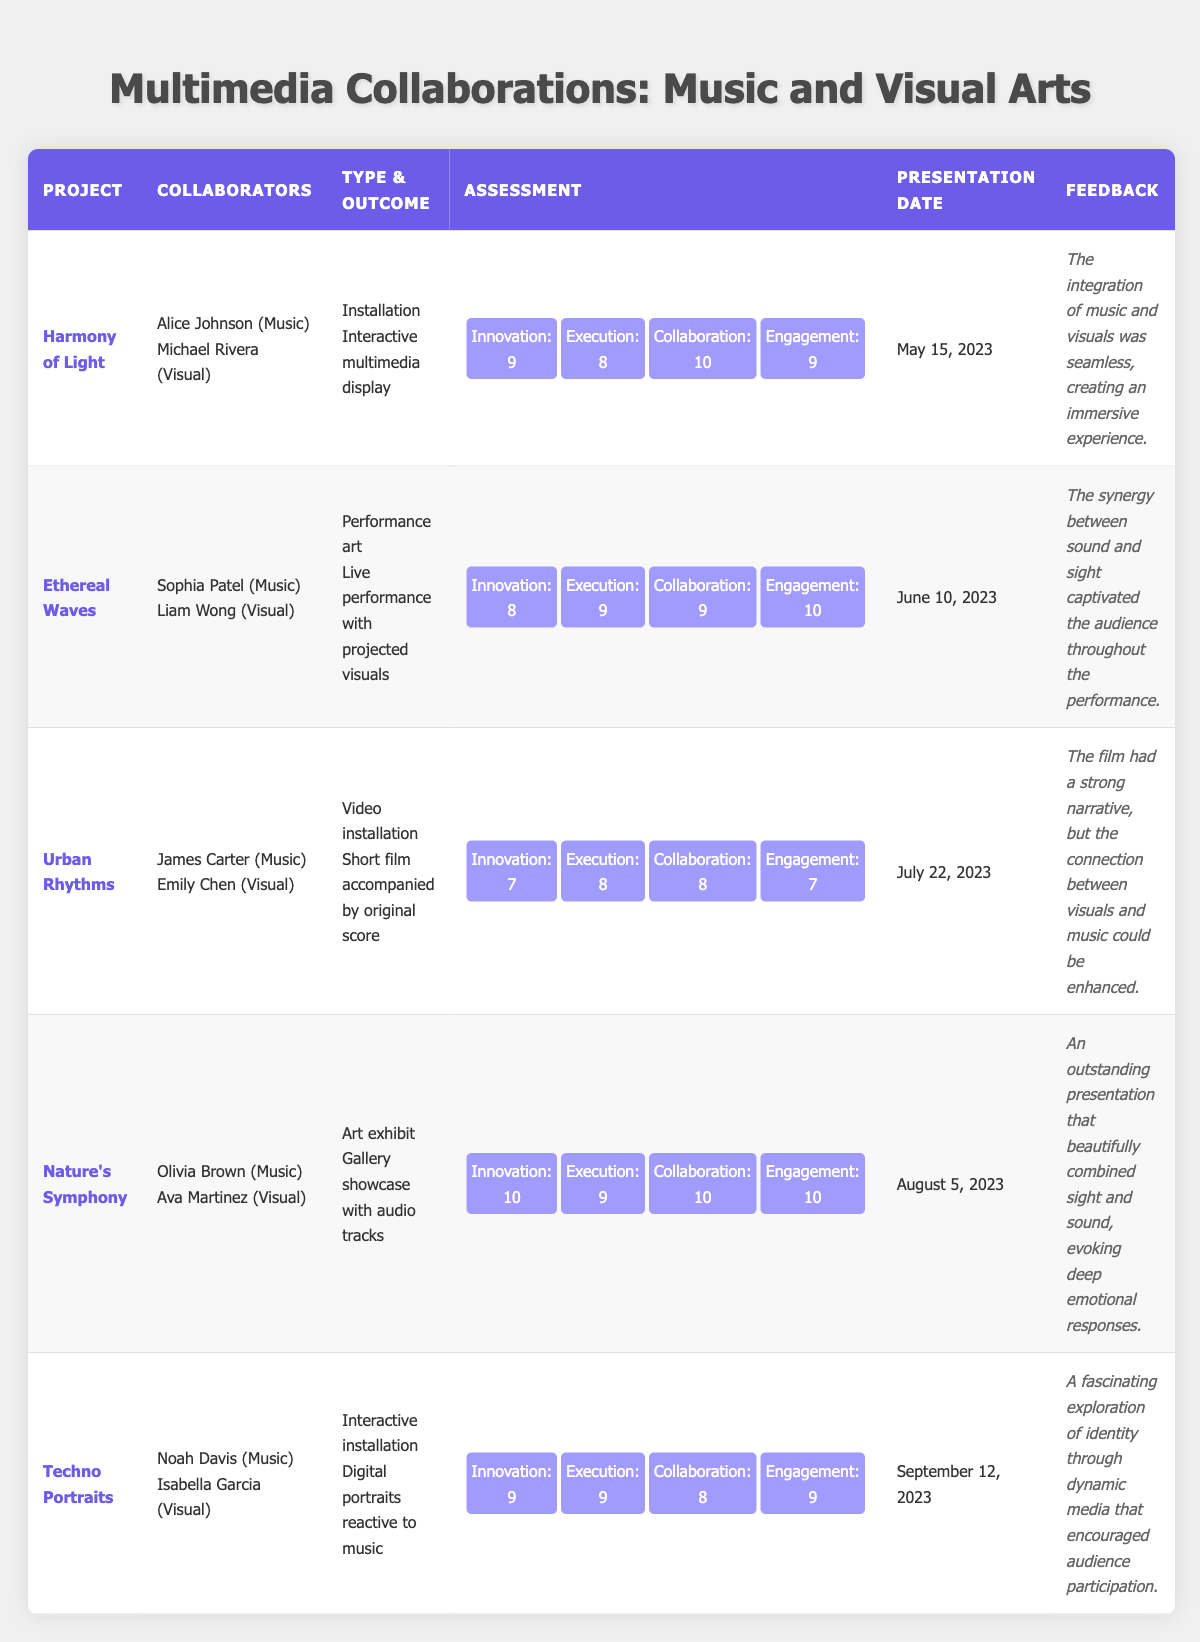What was the outcome of the "Ethereal Waves" project? The table indicates that the "Ethereal Waves" project resulted in a live performance with projected visuals.
Answer: Live performance with projected visuals Who were the collaborators for the project titled "Techno Portraits"? In the table, it lists Noah Davis as the music student and Isabella Garcia as the visual artist for the "Techno Portraits" project.
Answer: Noah Davis and Isabella Garcia What is the highest score in collaboration effort among the projects? By reviewing the assessment scores in the table, the highest score for collaborative effort is 10, achieved by both "Harmony of Light" and "Nature's Symphony."
Answer: 10 Did the "Urban Rhythms" project have a higher audience engagement score than the "Ethereal Waves"? The audience engagement score for "Urban Rhythms" is 7, while for "Ethereal Waves," it is 10. Since 7 is less than 10, the statement is false.
Answer: No What is the average innovation score for all projects? Adding the innovation scores (9 + 8 + 7 + 10 + 9 = 43) gives a total of 43. Dividing by the number of projects (5), the average innovation score is 43/5 = 8.6.
Answer: 8.6 Which project received the most positive feedback? Upon reviewing the feedback, "Nature's Symphony" received highly positive feedback, describing it as an outstanding presentation that evoked deep emotional responses, more positive than others.
Answer: Nature's Symphony Is there a project that received a perfect score in innovation? The table shows that "Nature's Symphony" received a perfect score of 10 in innovation, indicating that at least one project achieved this score.
Answer: Yes Which project had the lowest audience engagement score? Checking the audience engagement scores of each project, "Urban Rhythms" has the lowest score at 7 compared to the others.
Answer: Urban Rhythms What is the total execution score for all projects combined? Summing the execution scores (8 + 9 + 8 + 9 + 9 = 43) gives a total execution score of 43 across all projects.
Answer: 43 How many projects were presented on or after August 5, 2023? Reviewing the presentation dates, "Techno Portraits" (September 12) is the only project presented after August 5, 2023, making the total count 1.
Answer: 1 